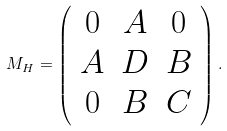<formula> <loc_0><loc_0><loc_500><loc_500>M _ { H } = \left ( \begin{array} { c c c } { 0 } & { A } & { 0 } \\ { A } & { D } & { B } \\ { 0 } & { B } & { C } \end{array} \right ) .</formula> 